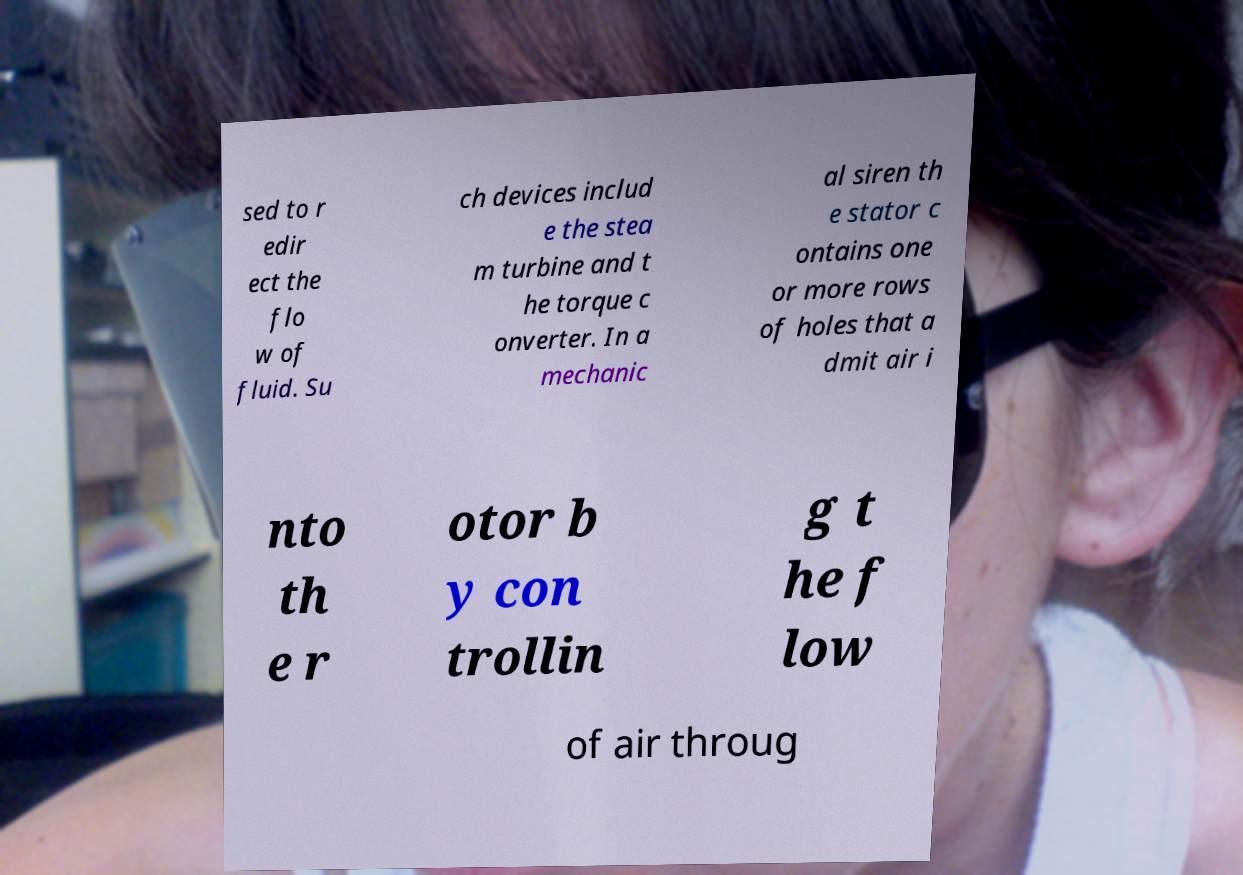For documentation purposes, I need the text within this image transcribed. Could you provide that? sed to r edir ect the flo w of fluid. Su ch devices includ e the stea m turbine and t he torque c onverter. In a mechanic al siren th e stator c ontains one or more rows of holes that a dmit air i nto th e r otor b y con trollin g t he f low of air throug 